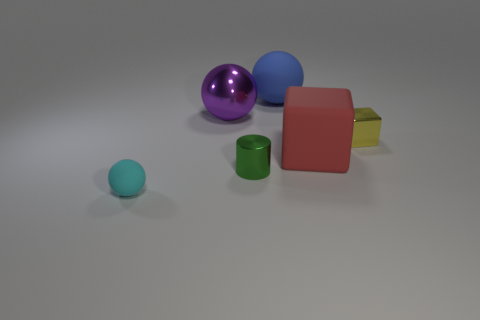Is the yellow metallic object the same shape as the small cyan object?
Offer a very short reply. No. Is the number of tiny metal cylinders that are on the left side of the tiny green object the same as the number of big red things?
Your answer should be compact. No. What number of other things are the same material as the big purple object?
Make the answer very short. 2. Is the size of the metallic thing that is on the right side of the blue rubber object the same as the rubber thing in front of the green object?
Provide a short and direct response. Yes. What number of objects are either matte spheres in front of the big purple shiny thing or matte balls that are in front of the blue object?
Your answer should be very brief. 1. Is there anything else that has the same shape as the large purple object?
Offer a terse response. Yes. Do the metallic thing in front of the tiny yellow metal thing and the large ball that is in front of the blue object have the same color?
Give a very brief answer. No. What number of metal things are yellow cubes or small cyan objects?
Ensure brevity in your answer.  1. Is there anything else that has the same size as the green metallic object?
Offer a very short reply. Yes. There is a big thing that is left of the sphere on the right side of the shiny sphere; what shape is it?
Make the answer very short. Sphere. 